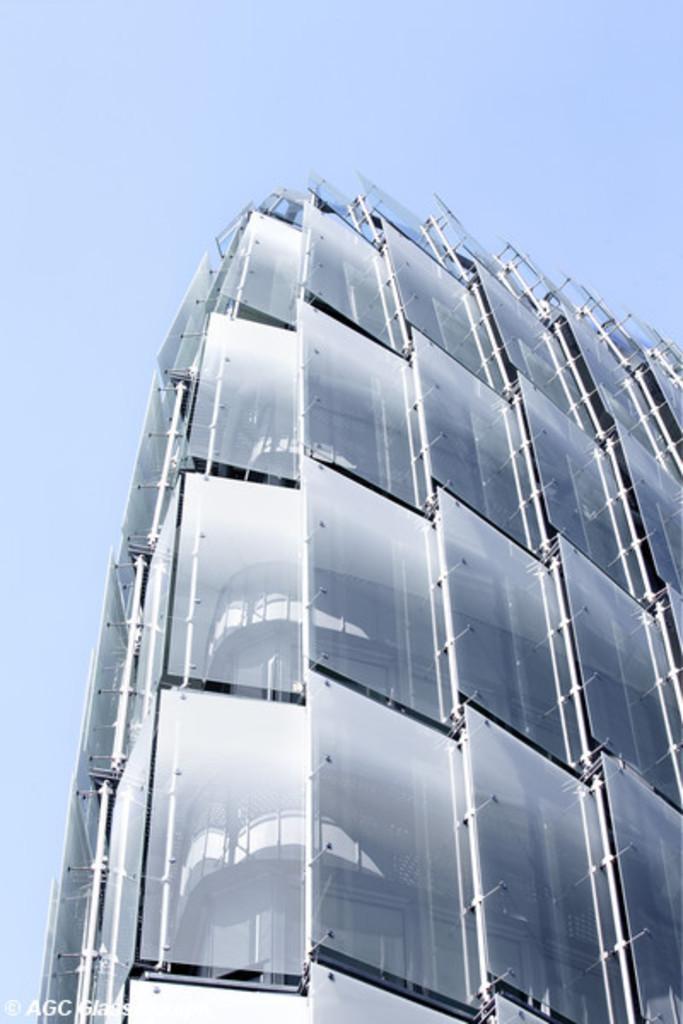Can you describe this image briefly? The picture consists of a building, to the building there are glasses attached. Sky is clear and it is sunny. 